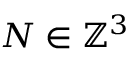Convert formula to latex. <formula><loc_0><loc_0><loc_500><loc_500>N \in \mathbb { Z } ^ { 3 }</formula> 